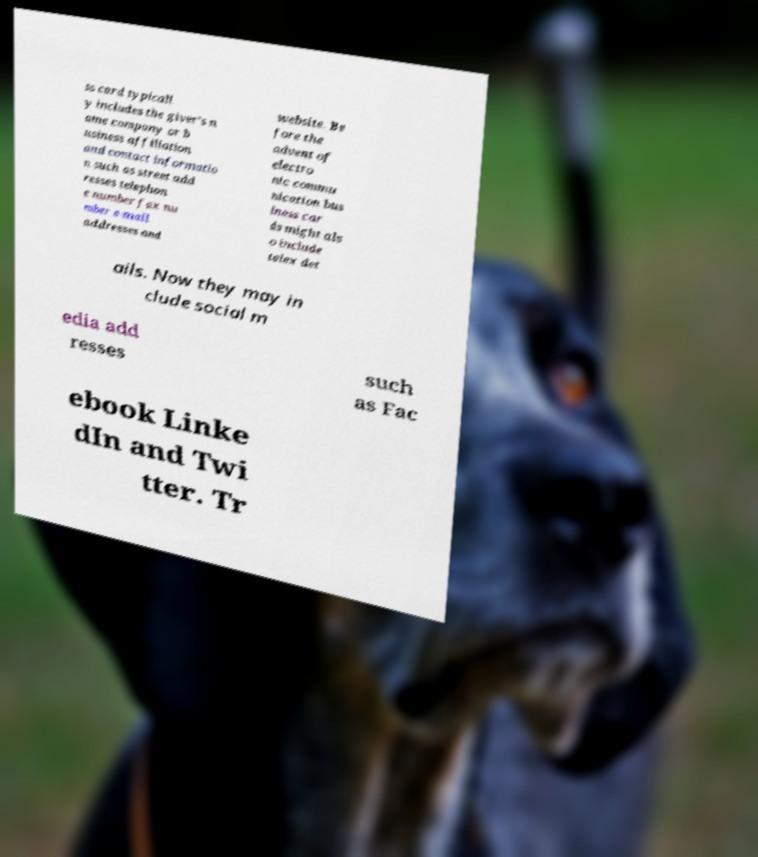Please identify and transcribe the text found in this image. ss card typicall y includes the giver's n ame company or b usiness affiliation and contact informatio n such as street add resses telephon e number fax nu mber e-mail addresses and website. Be fore the advent of electro nic commu nication bus iness car ds might als o include telex det ails. Now they may in clude social m edia add resses such as Fac ebook Linke dIn and Twi tter. Tr 